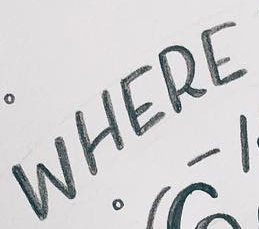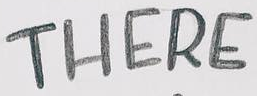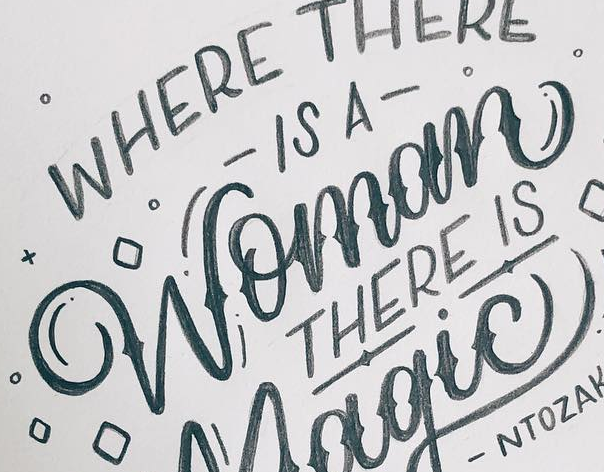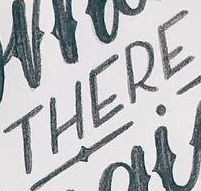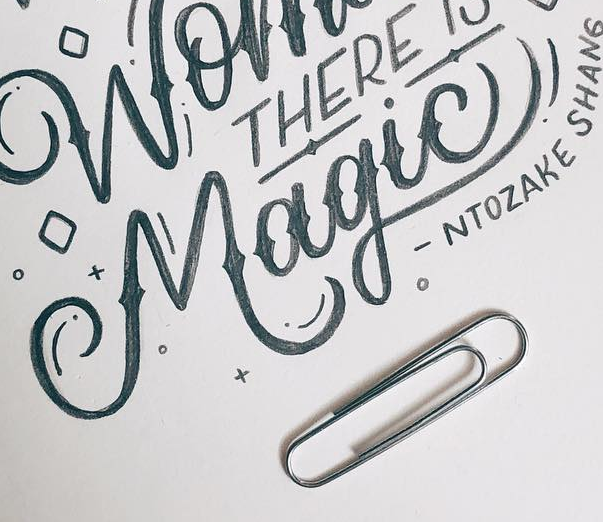What text appears in these images from left to right, separated by a semicolon? WHERE; THERE; Womom; THERE; Magic! 